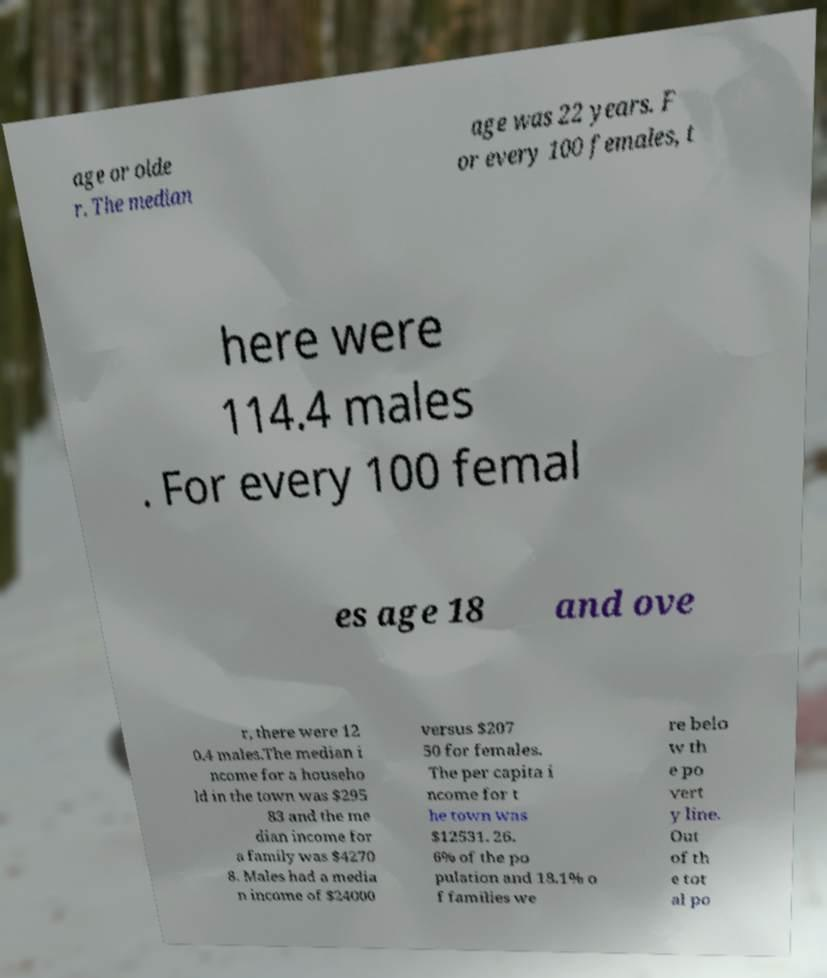Please read and relay the text visible in this image. What does it say? age or olde r. The median age was 22 years. F or every 100 females, t here were 114.4 males . For every 100 femal es age 18 and ove r, there were 12 0.4 males.The median i ncome for a househo ld in the town was $295 83 and the me dian income for a family was $4270 8. Males had a media n income of $24000 versus $207 50 for females. The per capita i ncome for t he town was $12531. 26. 6% of the po pulation and 18.1% o f families we re belo w th e po vert y line. Out of th e tot al po 